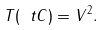<formula> <loc_0><loc_0><loc_500><loc_500>T ( \ t C ) = V ^ { 2 } .</formula> 